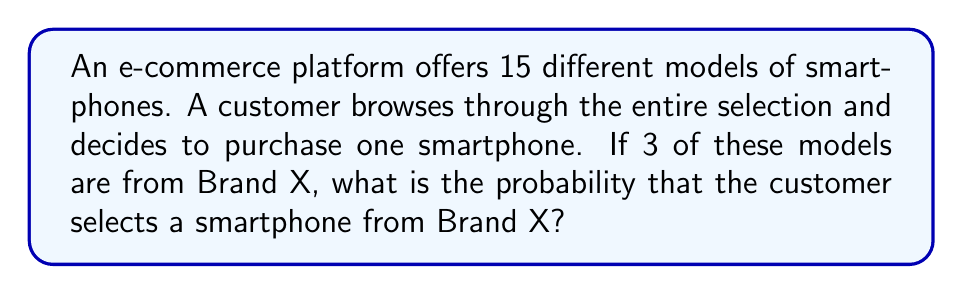Can you answer this question? To solve this problem, we need to use the concept of probability in a finite sample space. Let's break it down step-by-step:

1. Define the sample space:
   The sample space is the total number of possible outcomes, which in this case is the total number of smartphone models available.
   $n(\text{Sample Space}) = 15$

2. Define the event:
   The event we're interested in is selecting a smartphone from Brand X.
   $n(\text{Event}) = 3$

3. Calculate the probability:
   The probability of an event is the number of favorable outcomes divided by the total number of possible outcomes.

   $$P(\text{Brand X}) = \frac{n(\text{Event})}{n(\text{Sample Space})} = \frac{3}{15}$$

4. Simplify the fraction:
   $$P(\text{Brand X}) = \frac{3}{15} = \frac{1}{5} = 0.2$$

Therefore, the probability of the customer selecting a smartphone from Brand X is $\frac{1}{5}$ or 0.2 or 20%.
Answer: $\frac{1}{5}$ 